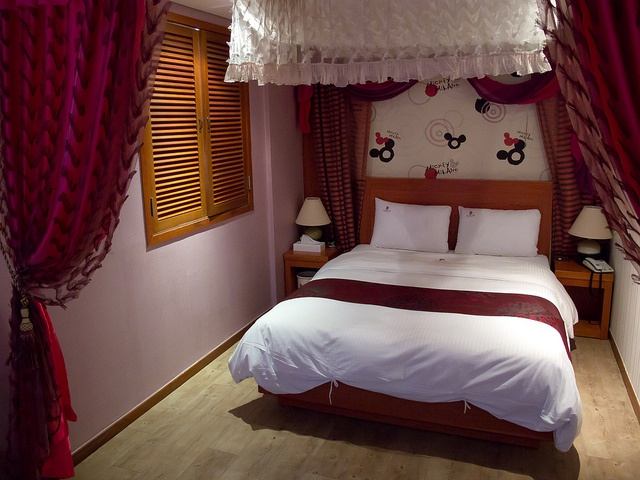Describe the objects in this image and their specific colors. I can see a bed in purple, darkgray, lightgray, gray, and maroon tones in this image. 